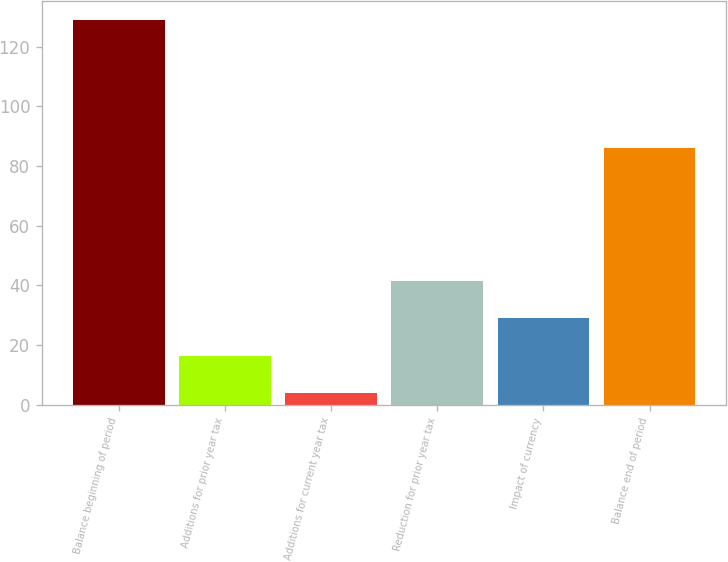<chart> <loc_0><loc_0><loc_500><loc_500><bar_chart><fcel>Balance beginning of period<fcel>Additions for prior year tax<fcel>Additions for current year tax<fcel>Reduction for prior year tax<fcel>Impact of currency<fcel>Balance end of period<nl><fcel>129<fcel>16.5<fcel>4<fcel>41.5<fcel>29<fcel>86<nl></chart> 